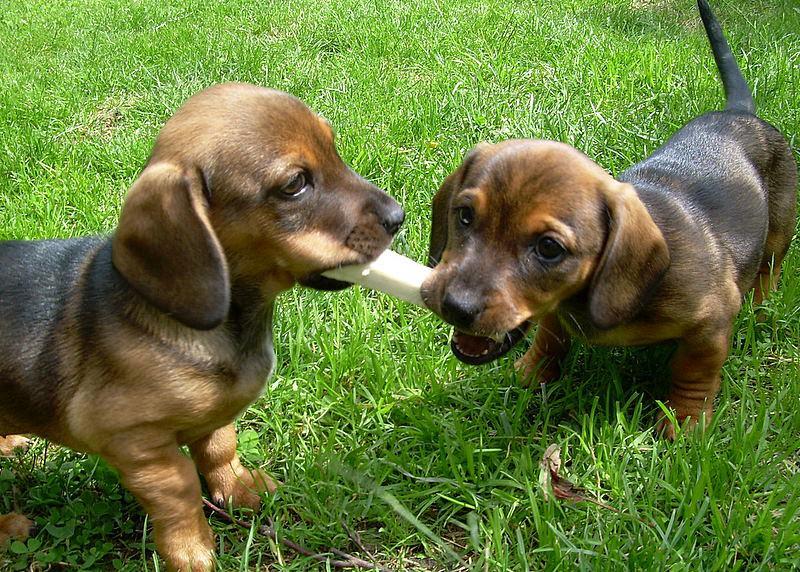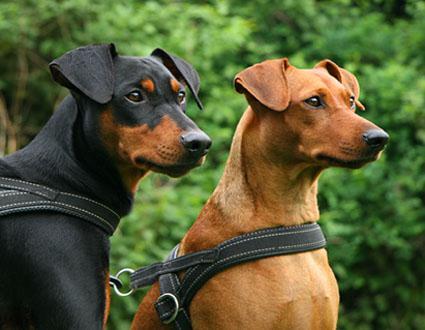The first image is the image on the left, the second image is the image on the right. Given the left and right images, does the statement "Each image contains a pair of animals, but one image features puppies and the other features adult dogs." hold true? Answer yes or no. Yes. The first image is the image on the left, the second image is the image on the right. Assess this claim about the two images: "At least one dog is sitting on a tile floor.". Correct or not? Answer yes or no. No. 